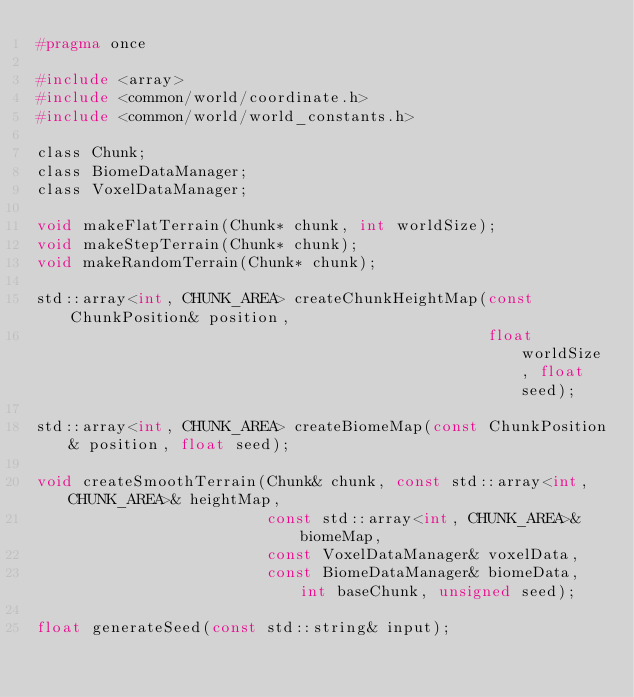<code> <loc_0><loc_0><loc_500><loc_500><_C_>#pragma once

#include <array>
#include <common/world/coordinate.h>
#include <common/world/world_constants.h>

class Chunk;
class BiomeDataManager;
class VoxelDataManager;

void makeFlatTerrain(Chunk* chunk, int worldSize);
void makeStepTerrain(Chunk* chunk);
void makeRandomTerrain(Chunk* chunk);

std::array<int, CHUNK_AREA> createChunkHeightMap(const ChunkPosition& position,
                                                 float worldSize, float seed);

std::array<int, CHUNK_AREA> createBiomeMap(const ChunkPosition& position, float seed);

void createSmoothTerrain(Chunk& chunk, const std::array<int, CHUNK_AREA>& heightMap,
                         const std::array<int, CHUNK_AREA>& biomeMap,
                         const VoxelDataManager& voxelData,
                         const BiomeDataManager& biomeData, int baseChunk, unsigned seed);

float generateSeed(const std::string& input);</code> 